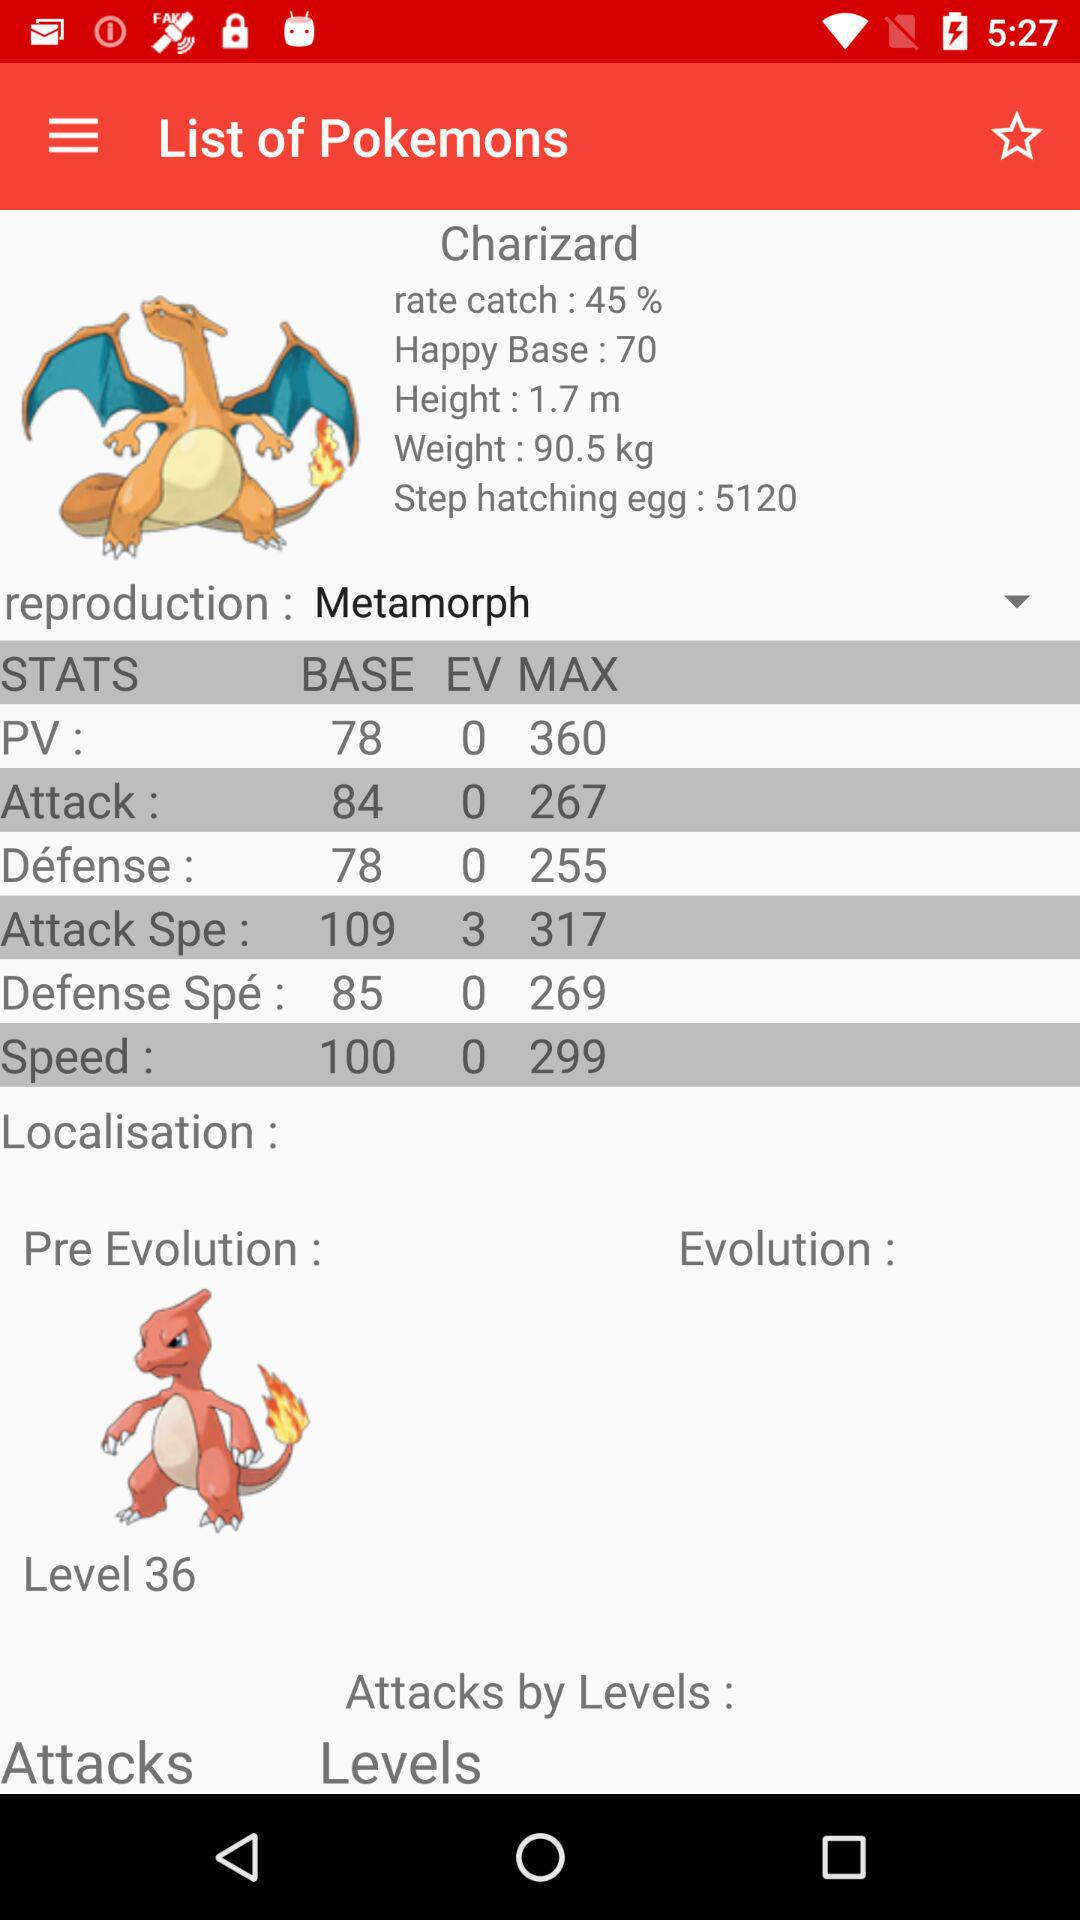What is the value of the happy base? The value of the happy base is 70. 